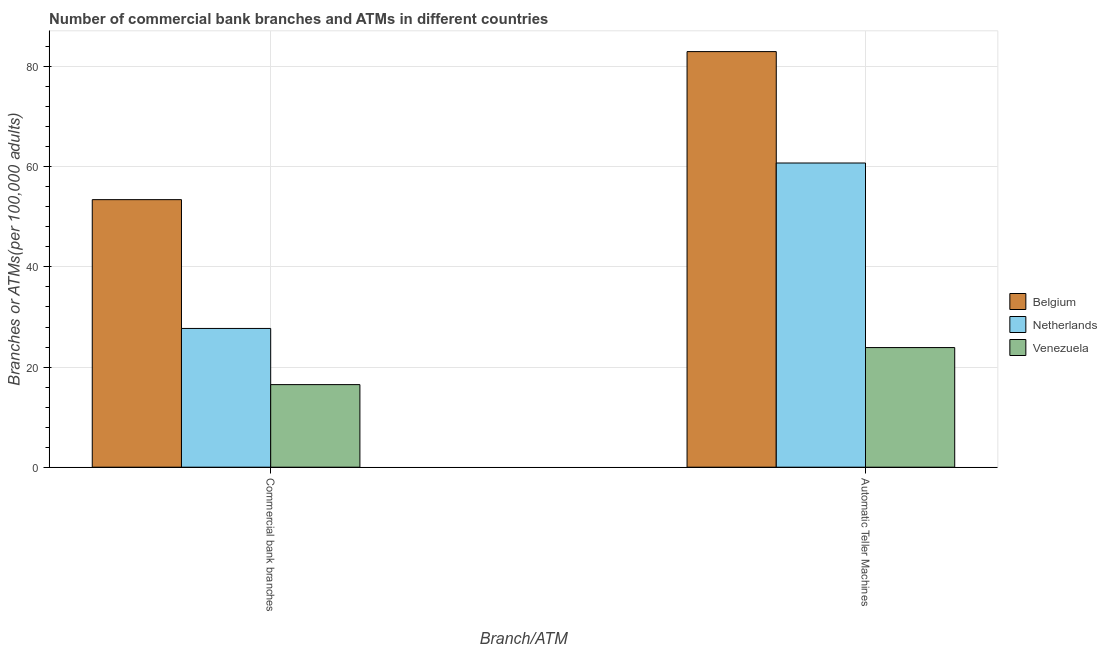How many different coloured bars are there?
Make the answer very short. 3. How many groups of bars are there?
Provide a succinct answer. 2. Are the number of bars per tick equal to the number of legend labels?
Give a very brief answer. Yes. How many bars are there on the 1st tick from the left?
Make the answer very short. 3. What is the label of the 2nd group of bars from the left?
Make the answer very short. Automatic Teller Machines. What is the number of commercal bank branches in Venezuela?
Provide a short and direct response. 16.5. Across all countries, what is the maximum number of atms?
Make the answer very short. 83.01. Across all countries, what is the minimum number of commercal bank branches?
Provide a succinct answer. 16.5. In which country was the number of commercal bank branches minimum?
Offer a very short reply. Venezuela. What is the total number of atms in the graph?
Your response must be concise. 167.66. What is the difference between the number of commercal bank branches in Belgium and that in Netherlands?
Your answer should be very brief. 25.73. What is the difference between the number of commercal bank branches in Belgium and the number of atms in Venezuela?
Offer a very short reply. 29.55. What is the average number of atms per country?
Provide a short and direct response. 55.89. What is the difference between the number of commercal bank branches and number of atms in Venezuela?
Your answer should be compact. -7.4. In how many countries, is the number of commercal bank branches greater than 12 ?
Provide a succinct answer. 3. What is the ratio of the number of atms in Netherlands to that in Venezuela?
Provide a succinct answer. 2.54. Is the number of atms in Belgium less than that in Netherlands?
Ensure brevity in your answer.  No. In how many countries, is the number of commercal bank branches greater than the average number of commercal bank branches taken over all countries?
Provide a succinct answer. 1. What does the 1st bar from the right in Automatic Teller Machines represents?
Your answer should be very brief. Venezuela. Are all the bars in the graph horizontal?
Offer a very short reply. No. Where does the legend appear in the graph?
Offer a very short reply. Center right. What is the title of the graph?
Your response must be concise. Number of commercial bank branches and ATMs in different countries. Does "Papua New Guinea" appear as one of the legend labels in the graph?
Ensure brevity in your answer.  No. What is the label or title of the X-axis?
Your answer should be very brief. Branch/ATM. What is the label or title of the Y-axis?
Keep it short and to the point. Branches or ATMs(per 100,0 adults). What is the Branches or ATMs(per 100,000 adults) in Belgium in Commercial bank branches?
Provide a succinct answer. 53.44. What is the Branches or ATMs(per 100,000 adults) in Netherlands in Commercial bank branches?
Keep it short and to the point. 27.71. What is the Branches or ATMs(per 100,000 adults) of Venezuela in Commercial bank branches?
Offer a terse response. 16.5. What is the Branches or ATMs(per 100,000 adults) of Belgium in Automatic Teller Machines?
Give a very brief answer. 83.01. What is the Branches or ATMs(per 100,000 adults) in Netherlands in Automatic Teller Machines?
Give a very brief answer. 60.76. What is the Branches or ATMs(per 100,000 adults) in Venezuela in Automatic Teller Machines?
Keep it short and to the point. 23.89. Across all Branch/ATM, what is the maximum Branches or ATMs(per 100,000 adults) of Belgium?
Give a very brief answer. 83.01. Across all Branch/ATM, what is the maximum Branches or ATMs(per 100,000 adults) of Netherlands?
Your response must be concise. 60.76. Across all Branch/ATM, what is the maximum Branches or ATMs(per 100,000 adults) in Venezuela?
Offer a very short reply. 23.89. Across all Branch/ATM, what is the minimum Branches or ATMs(per 100,000 adults) of Belgium?
Offer a very short reply. 53.44. Across all Branch/ATM, what is the minimum Branches or ATMs(per 100,000 adults) in Netherlands?
Give a very brief answer. 27.71. Across all Branch/ATM, what is the minimum Branches or ATMs(per 100,000 adults) in Venezuela?
Your answer should be compact. 16.5. What is the total Branches or ATMs(per 100,000 adults) of Belgium in the graph?
Keep it short and to the point. 136.45. What is the total Branches or ATMs(per 100,000 adults) of Netherlands in the graph?
Your answer should be very brief. 88.47. What is the total Branches or ATMs(per 100,000 adults) of Venezuela in the graph?
Ensure brevity in your answer.  40.39. What is the difference between the Branches or ATMs(per 100,000 adults) in Belgium in Commercial bank branches and that in Automatic Teller Machines?
Provide a short and direct response. -29.57. What is the difference between the Branches or ATMs(per 100,000 adults) of Netherlands in Commercial bank branches and that in Automatic Teller Machines?
Make the answer very short. -33.05. What is the difference between the Branches or ATMs(per 100,000 adults) of Venezuela in Commercial bank branches and that in Automatic Teller Machines?
Your response must be concise. -7.4. What is the difference between the Branches or ATMs(per 100,000 adults) in Belgium in Commercial bank branches and the Branches or ATMs(per 100,000 adults) in Netherlands in Automatic Teller Machines?
Provide a succinct answer. -7.32. What is the difference between the Branches or ATMs(per 100,000 adults) in Belgium in Commercial bank branches and the Branches or ATMs(per 100,000 adults) in Venezuela in Automatic Teller Machines?
Provide a short and direct response. 29.55. What is the difference between the Branches or ATMs(per 100,000 adults) in Netherlands in Commercial bank branches and the Branches or ATMs(per 100,000 adults) in Venezuela in Automatic Teller Machines?
Your answer should be compact. 3.82. What is the average Branches or ATMs(per 100,000 adults) in Belgium per Branch/ATM?
Ensure brevity in your answer.  68.22. What is the average Branches or ATMs(per 100,000 adults) in Netherlands per Branch/ATM?
Provide a short and direct response. 44.24. What is the average Branches or ATMs(per 100,000 adults) of Venezuela per Branch/ATM?
Your answer should be very brief. 20.19. What is the difference between the Branches or ATMs(per 100,000 adults) of Belgium and Branches or ATMs(per 100,000 adults) of Netherlands in Commercial bank branches?
Keep it short and to the point. 25.73. What is the difference between the Branches or ATMs(per 100,000 adults) of Belgium and Branches or ATMs(per 100,000 adults) of Venezuela in Commercial bank branches?
Provide a short and direct response. 36.94. What is the difference between the Branches or ATMs(per 100,000 adults) in Netherlands and Branches or ATMs(per 100,000 adults) in Venezuela in Commercial bank branches?
Make the answer very short. 11.22. What is the difference between the Branches or ATMs(per 100,000 adults) in Belgium and Branches or ATMs(per 100,000 adults) in Netherlands in Automatic Teller Machines?
Your answer should be very brief. 22.25. What is the difference between the Branches or ATMs(per 100,000 adults) in Belgium and Branches or ATMs(per 100,000 adults) in Venezuela in Automatic Teller Machines?
Ensure brevity in your answer.  59.11. What is the difference between the Branches or ATMs(per 100,000 adults) in Netherlands and Branches or ATMs(per 100,000 adults) in Venezuela in Automatic Teller Machines?
Your response must be concise. 36.86. What is the ratio of the Branches or ATMs(per 100,000 adults) of Belgium in Commercial bank branches to that in Automatic Teller Machines?
Keep it short and to the point. 0.64. What is the ratio of the Branches or ATMs(per 100,000 adults) in Netherlands in Commercial bank branches to that in Automatic Teller Machines?
Offer a terse response. 0.46. What is the ratio of the Branches or ATMs(per 100,000 adults) in Venezuela in Commercial bank branches to that in Automatic Teller Machines?
Your answer should be very brief. 0.69. What is the difference between the highest and the second highest Branches or ATMs(per 100,000 adults) in Belgium?
Make the answer very short. 29.57. What is the difference between the highest and the second highest Branches or ATMs(per 100,000 adults) of Netherlands?
Keep it short and to the point. 33.05. What is the difference between the highest and the second highest Branches or ATMs(per 100,000 adults) of Venezuela?
Your answer should be compact. 7.4. What is the difference between the highest and the lowest Branches or ATMs(per 100,000 adults) of Belgium?
Provide a short and direct response. 29.57. What is the difference between the highest and the lowest Branches or ATMs(per 100,000 adults) of Netherlands?
Ensure brevity in your answer.  33.05. What is the difference between the highest and the lowest Branches or ATMs(per 100,000 adults) of Venezuela?
Your answer should be compact. 7.4. 